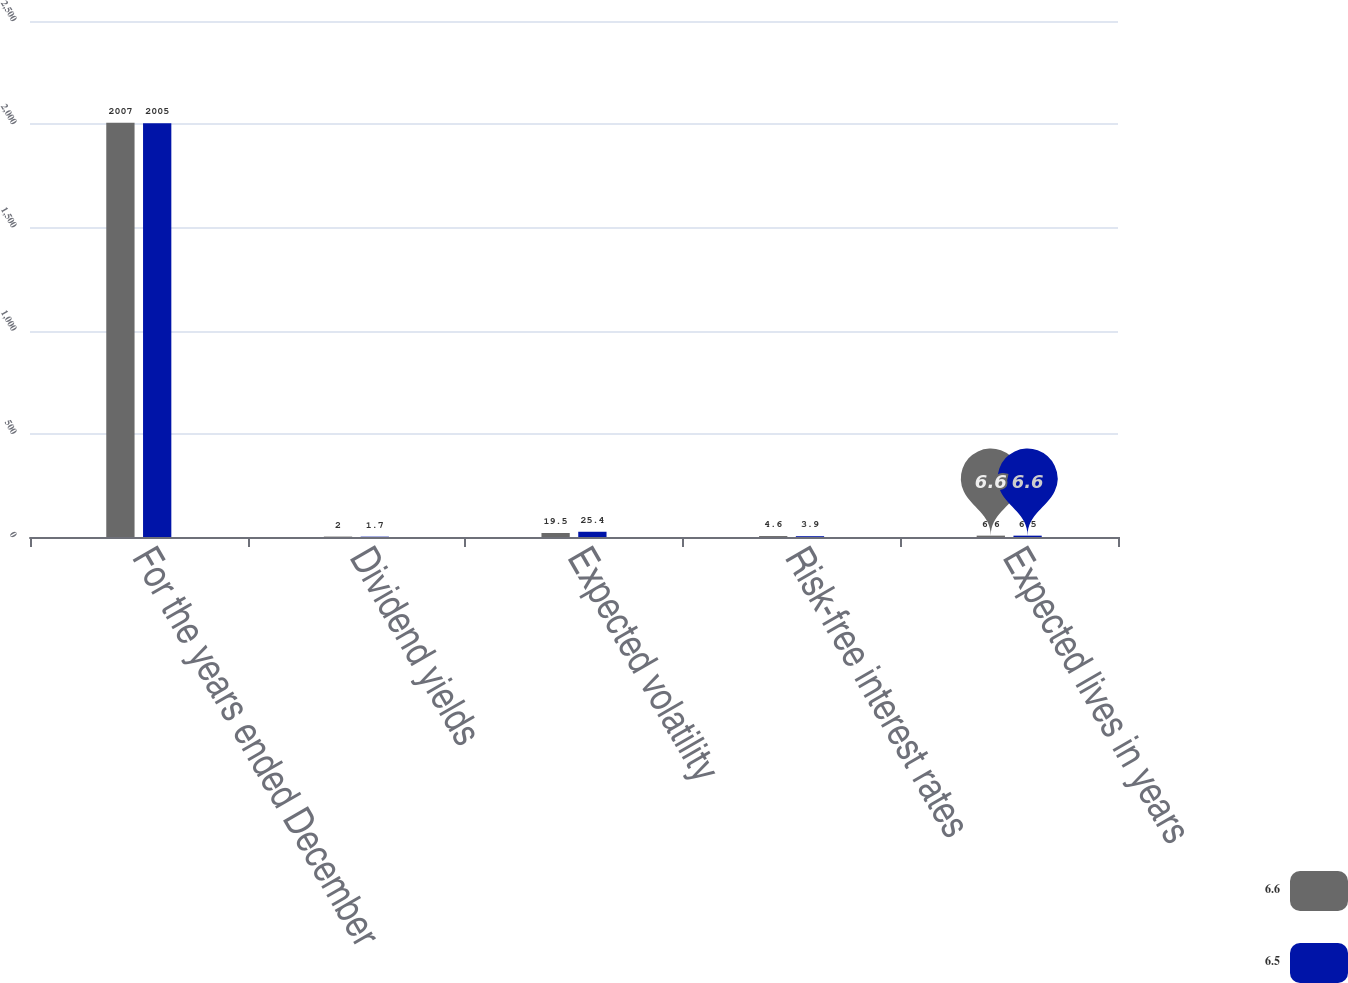Convert chart to OTSL. <chart><loc_0><loc_0><loc_500><loc_500><stacked_bar_chart><ecel><fcel>For the years ended December<fcel>Dividend yields<fcel>Expected volatility<fcel>Risk-free interest rates<fcel>Expected lives in years<nl><fcel>6.6<fcel>2007<fcel>2<fcel>19.5<fcel>4.6<fcel>6.6<nl><fcel>6.5<fcel>2005<fcel>1.7<fcel>25.4<fcel>3.9<fcel>6.5<nl></chart> 